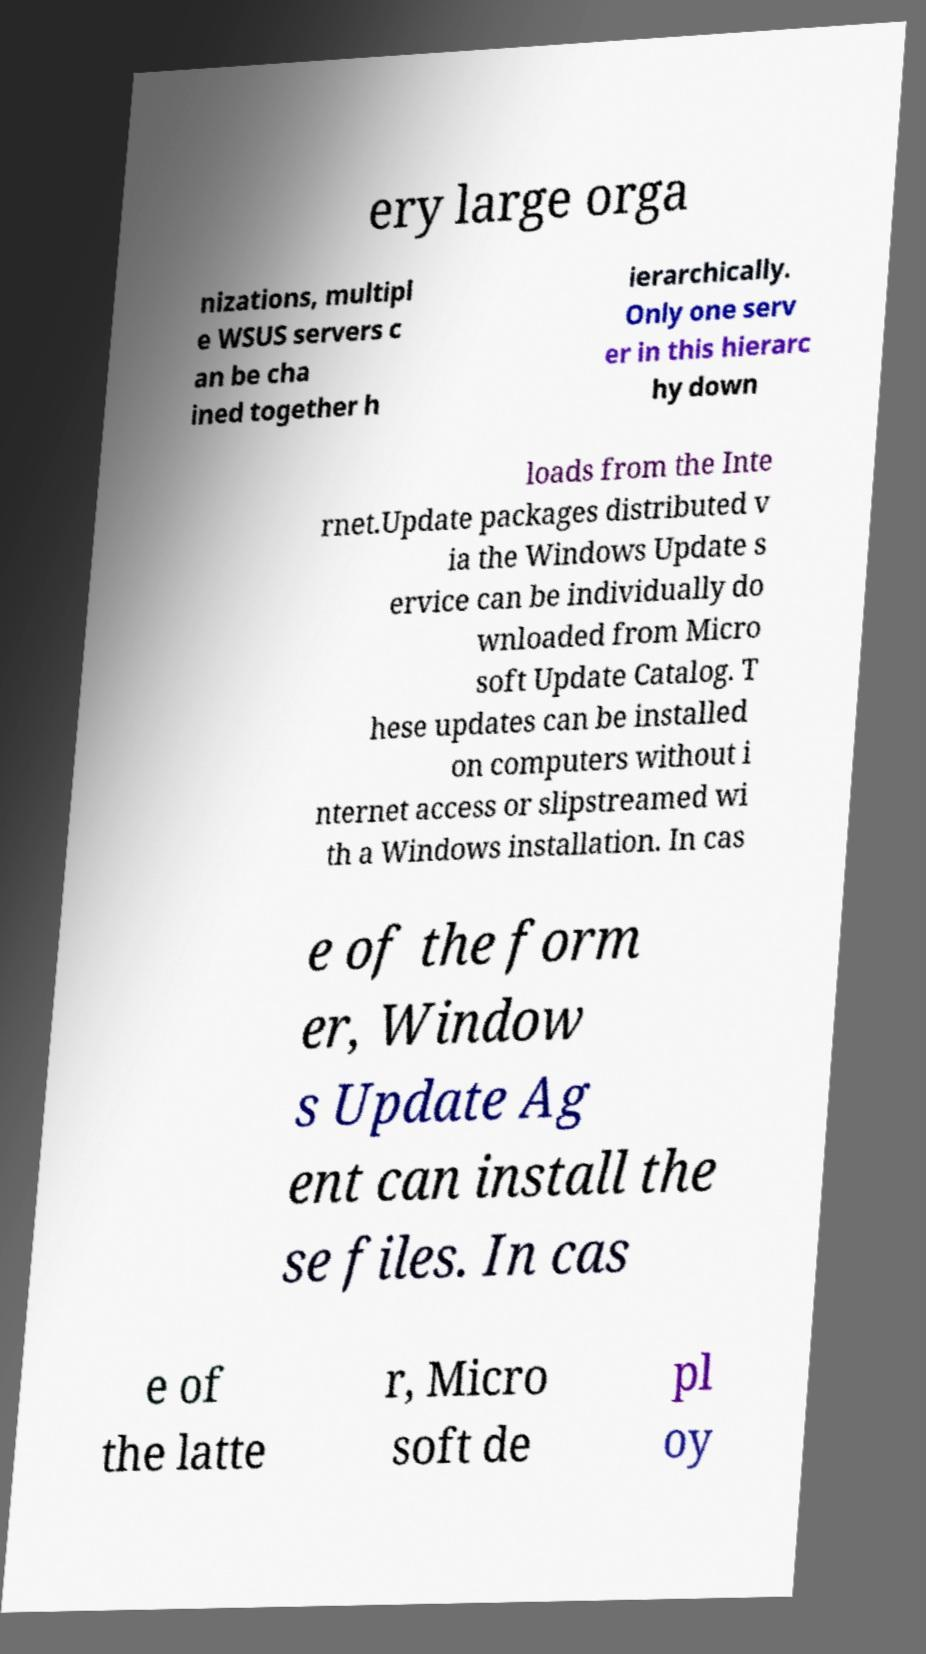Can you accurately transcribe the text from the provided image for me? ery large orga nizations, multipl e WSUS servers c an be cha ined together h ierarchically. Only one serv er in this hierarc hy down loads from the Inte rnet.Update packages distributed v ia the Windows Update s ervice can be individually do wnloaded from Micro soft Update Catalog. T hese updates can be installed on computers without i nternet access or slipstreamed wi th a Windows installation. In cas e of the form er, Window s Update Ag ent can install the se files. In cas e of the latte r, Micro soft de pl oy 